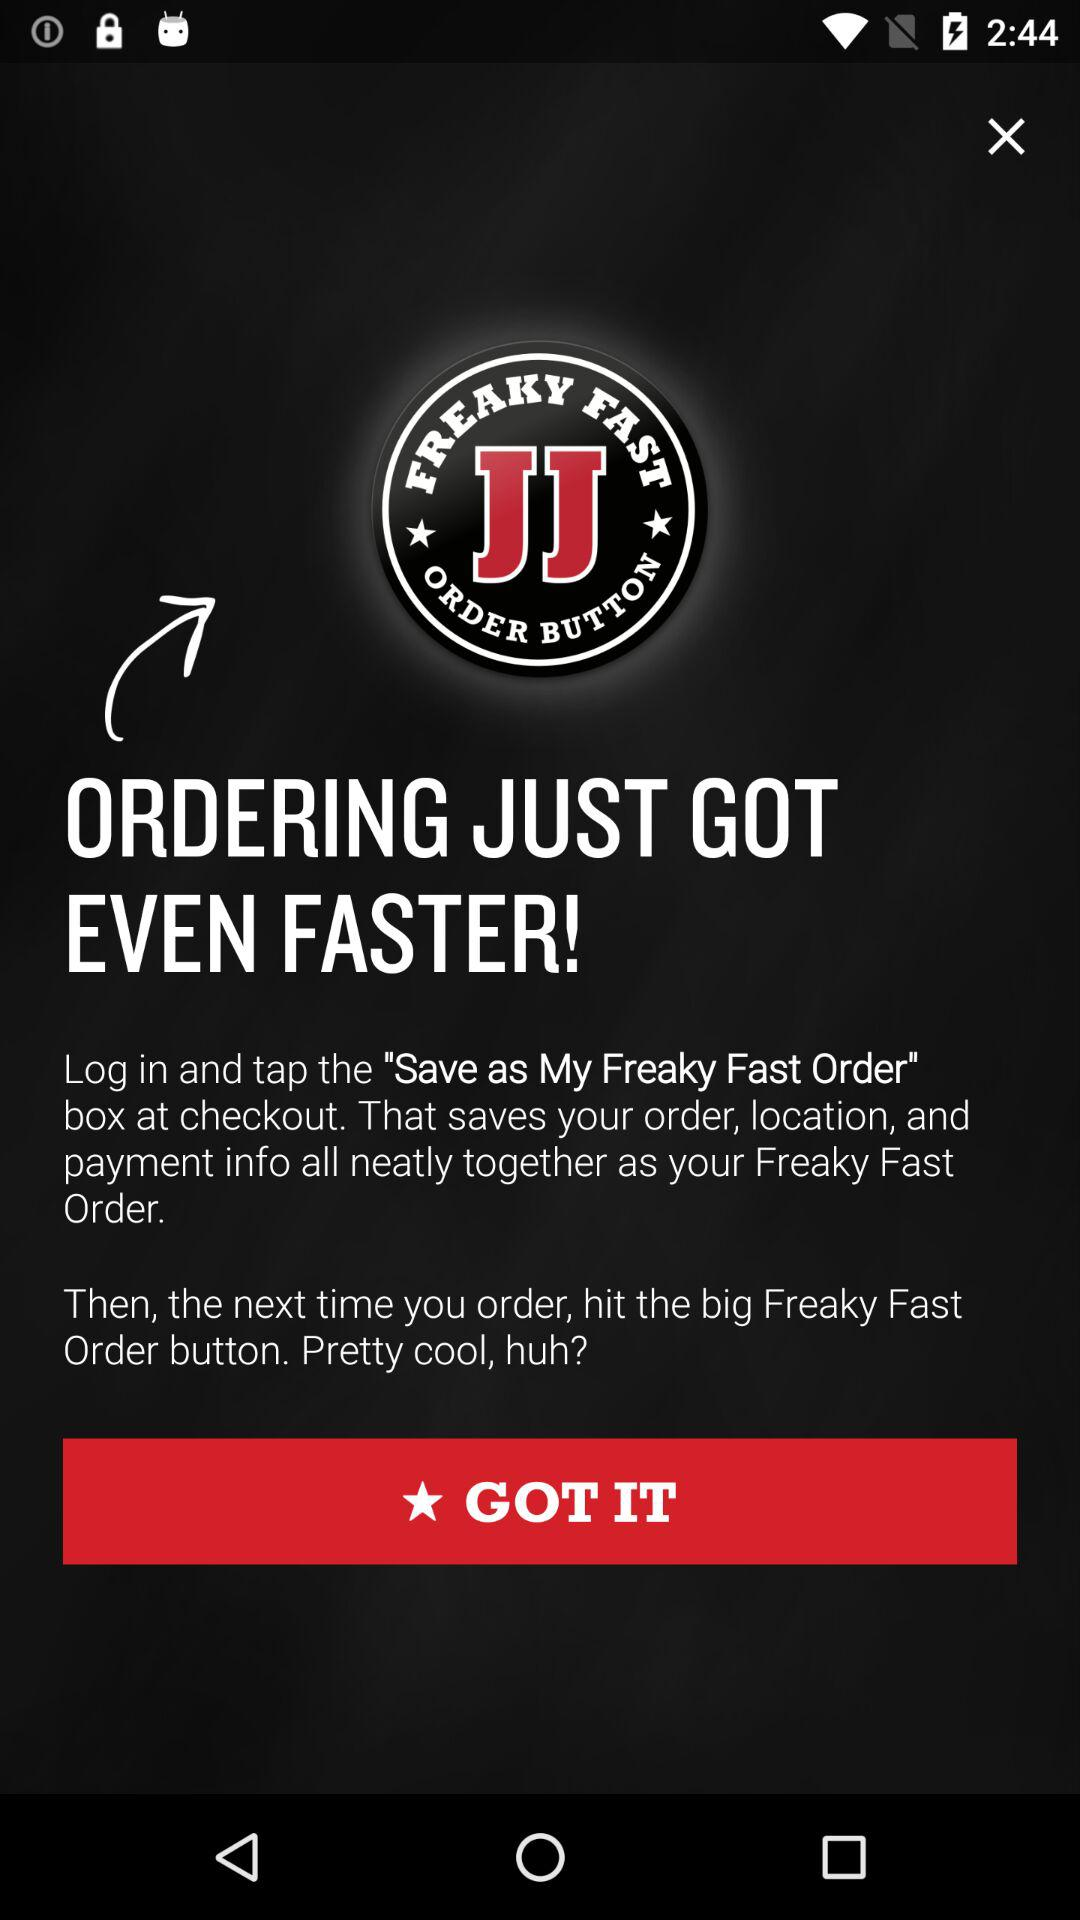What is the application name? The application name is "Freaky Fast". 